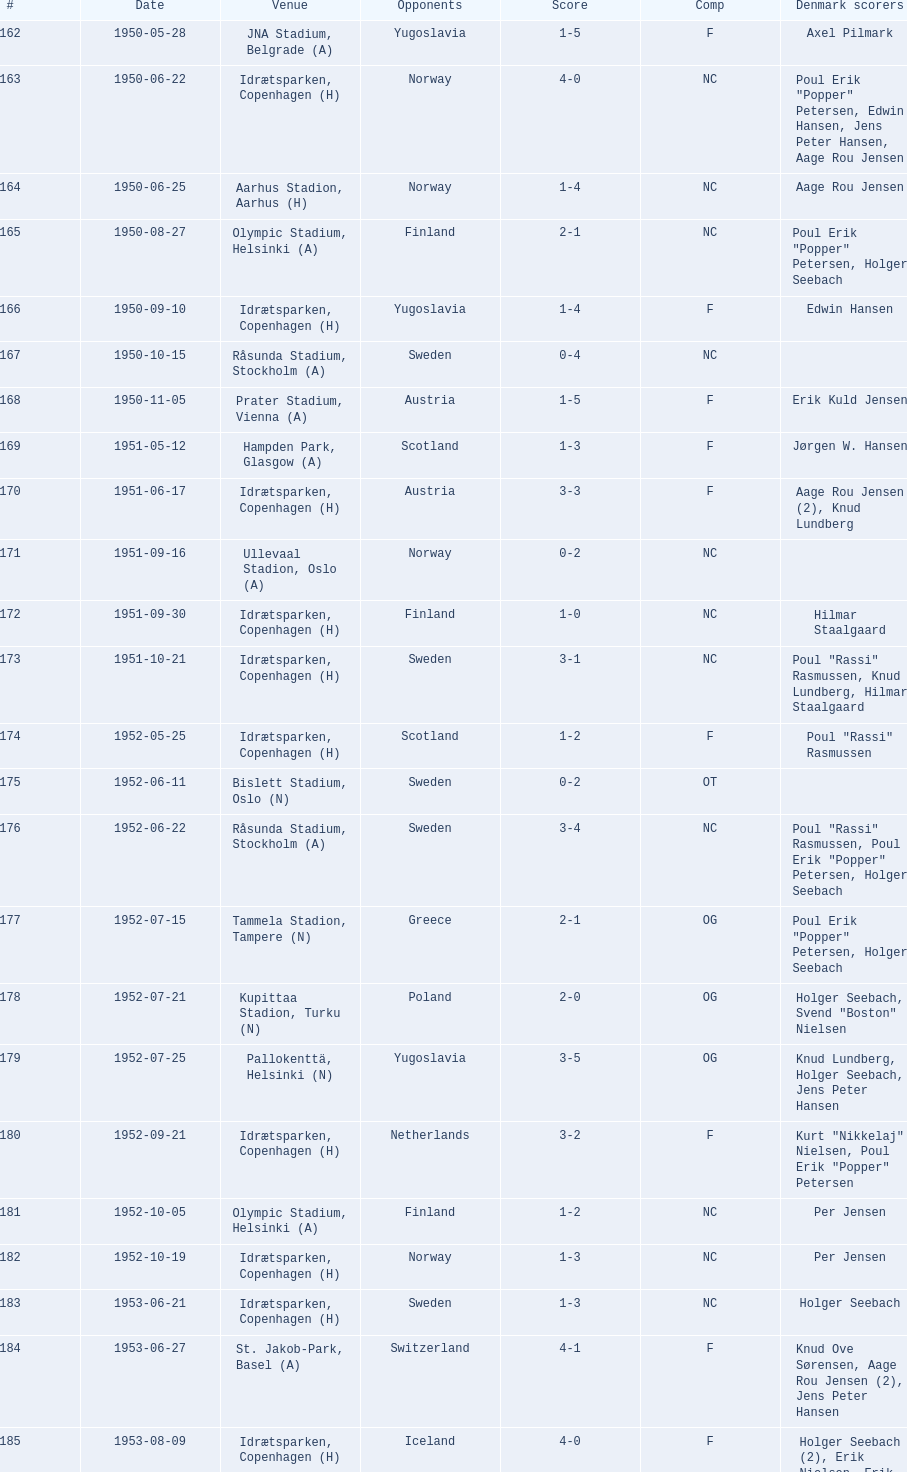How many times was poland the opponent? 2. 